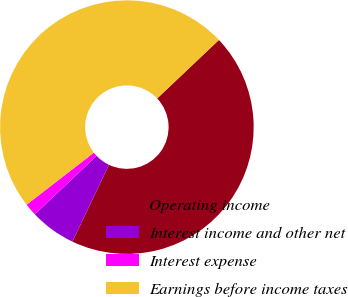<chart> <loc_0><loc_0><loc_500><loc_500><pie_chart><fcel>Operating income<fcel>Interest income and other net<fcel>Interest expense<fcel>Earnings before income taxes<nl><fcel>44.14%<fcel>5.86%<fcel>1.59%<fcel>48.41%<nl></chart> 